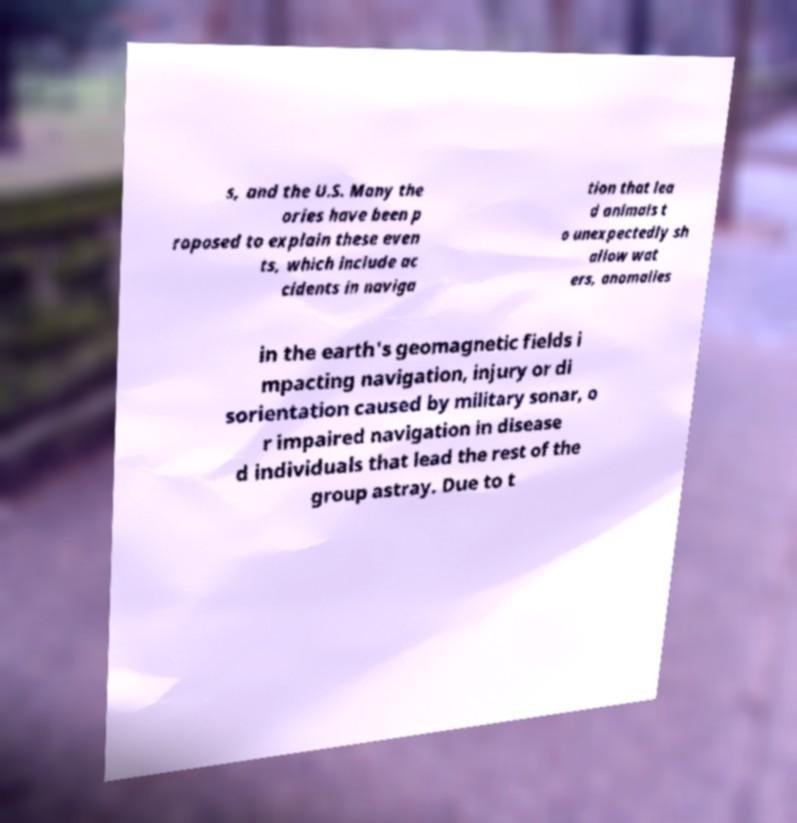Could you assist in decoding the text presented in this image and type it out clearly? s, and the U.S. Many the ories have been p roposed to explain these even ts, which include ac cidents in naviga tion that lea d animals t o unexpectedly sh allow wat ers, anomalies in the earth's geomagnetic fields i mpacting navigation, injury or di sorientation caused by military sonar, o r impaired navigation in disease d individuals that lead the rest of the group astray. Due to t 